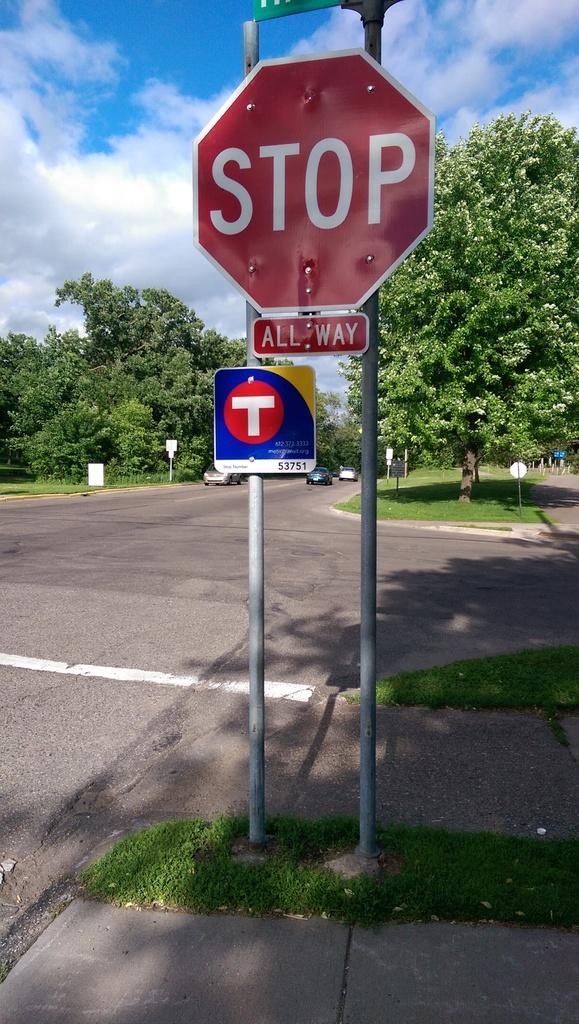What way is this stop sign?
Your response must be concise. All way. What does the bottom sign say?
Make the answer very short. All way. 